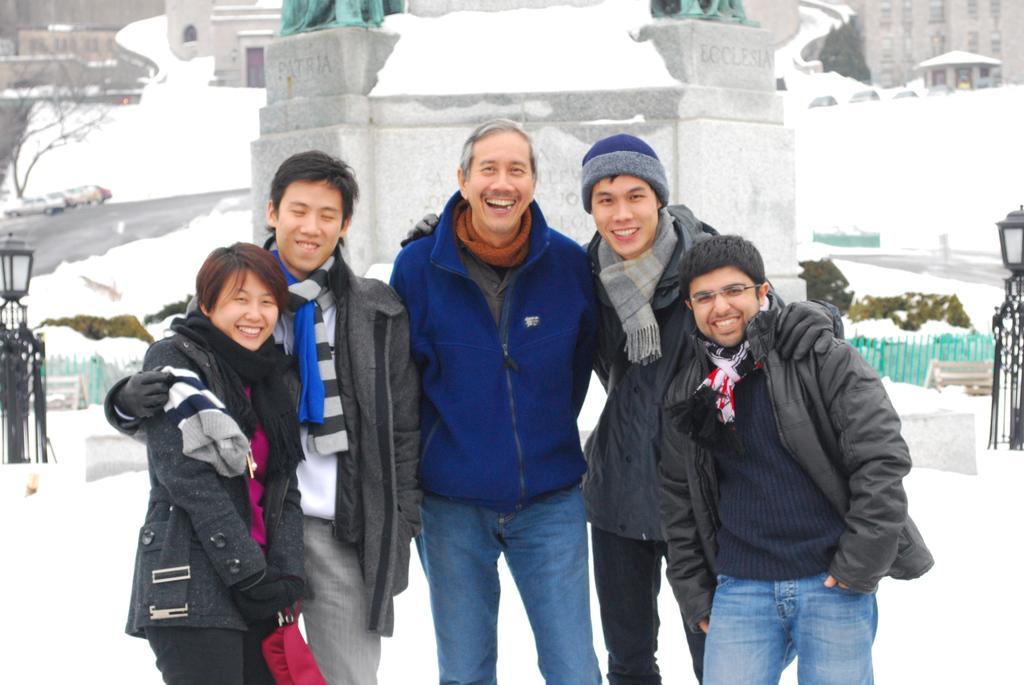How would you summarize this image in a sentence or two? In this image, we can see people standing and smiling and in the background, there are buildings, trees, lights and there is a fence. At the bottom, there is snow. 